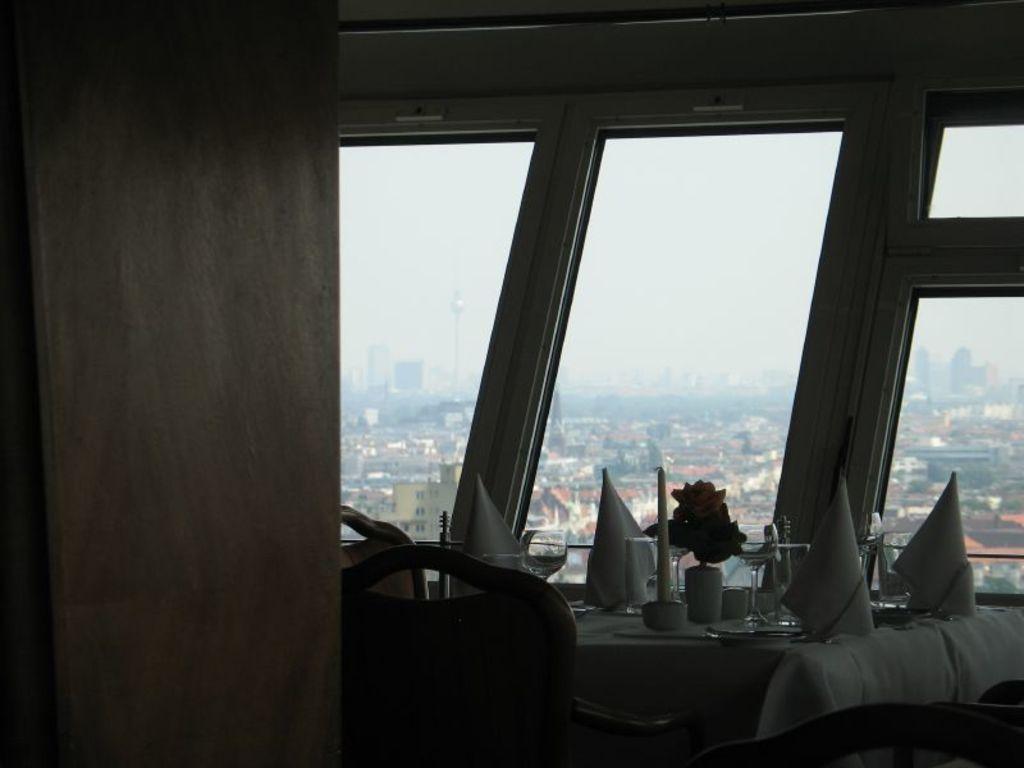Could you give a brief overview of what you see in this image? This image is clicked inside the room. In the front, we can see a table on which there are glasses and a candle along with a small potted plant. The table is covered with a white cloth. On the left, we can see chair. In the background, there are windows through which we can see the city. 